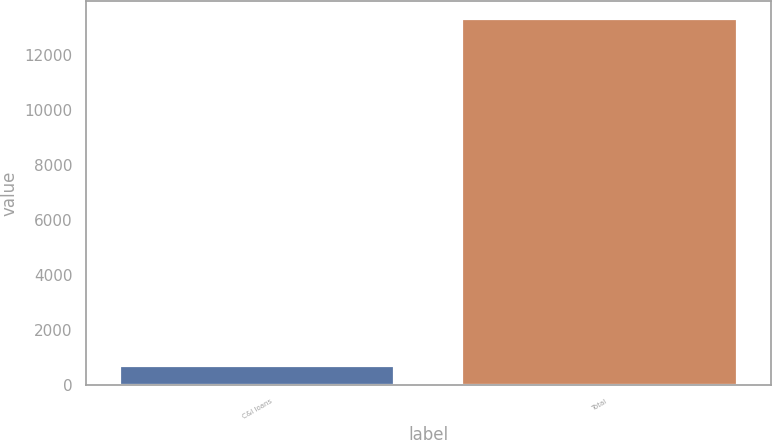Convert chart. <chart><loc_0><loc_0><loc_500><loc_500><bar_chart><fcel>C&I loans<fcel>Total<nl><fcel>696<fcel>13309<nl></chart> 